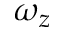Convert formula to latex. <formula><loc_0><loc_0><loc_500><loc_500>\omega _ { z }</formula> 